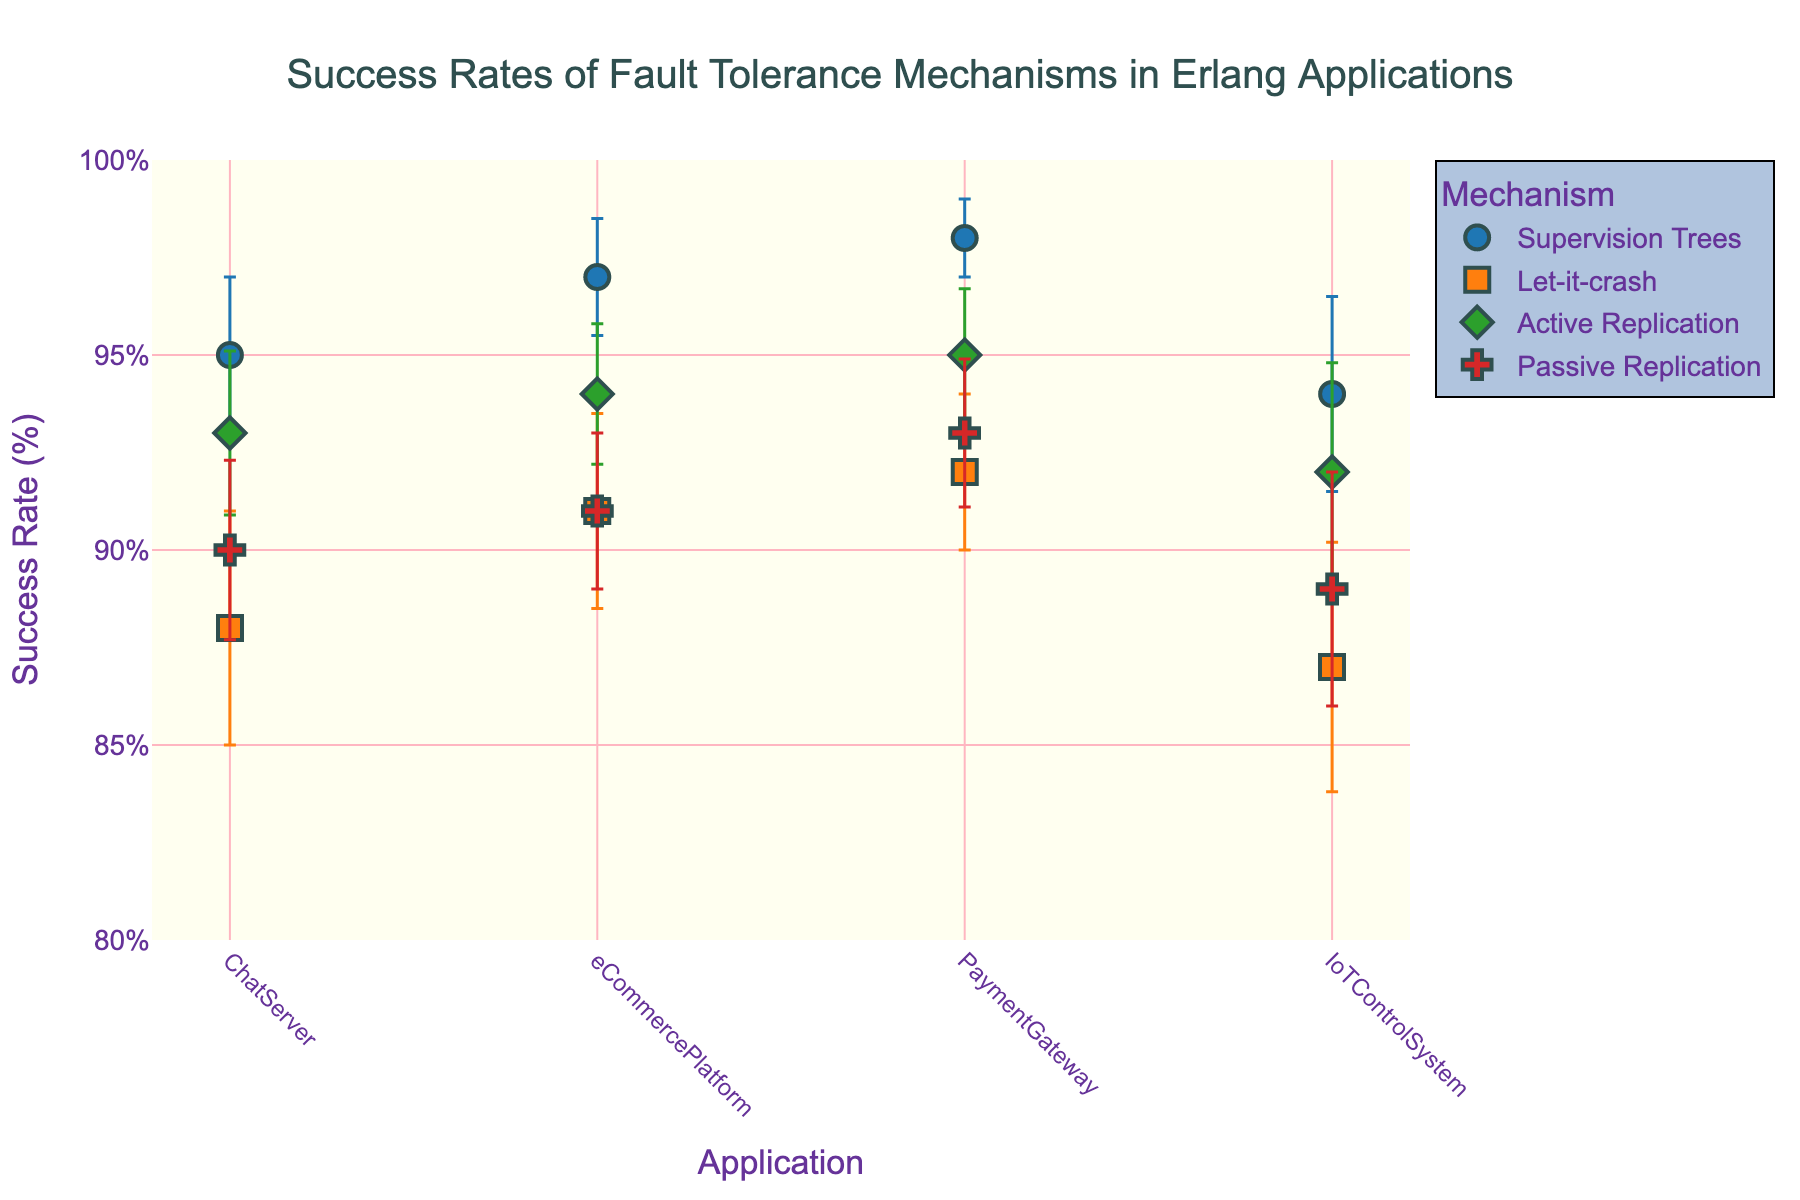What is the title of the figure? The title is displayed at the top center of the figure and reads "Success Rates of Fault Tolerance Mechanisms in Erlang Applications."
Answer: Success Rates of Fault Tolerance Mechanisms in Erlang Applications How many different applications are compared in the figure? The x-axis labels represent the different applications, and there are four distinct labels: ChatServer, eCommercePlatform, PaymentGateway, and IoTControlSystem.
Answer: 4 Which mechanism has the highest success rate for the PaymentGateway application? By observing the y-values corresponding to the "PaymentGateway" label, the highest success rate appears under "Supervision Trees" at 98%.
Answer: Supervision Trees What is the success rate for Active Replication in the ChatServer application? Locate the point corresponding to "Active Replication" for "ChatServer" on the x-axis, and check the y-axis for its success rate, which is 93%.
Answer: 93% How does the error margin of Supervision Trees for the IoTControlSystem compare to that of Let-it-crash for the same system? Observe the error bars for "Supervision Trees" and "Let-it-crash" for the "IoTControlSystem." "Supervision Trees" has an error margin of ±2.5%, while "Let-it-crash" has ±3.2%. Therefore, Let-it-crash has a higher error margin.
Answer: Let-it-crash has a higher error margin What is the combined error margin range for Passive Replication in the PaymentGateway application on the y-axis? The error margin is ±1.9%. Therefore, the success rate of 93% can range from 91.1% to 94.9%.
Answer: 91.1% to 94.9% Which mechanism shows the least average error margin across all applications? Observe the size of the error bars for each mechanism. "Supervision Trees" has the smallest error margins across all applications (1, 1.5, 2, 2.5) compared to others.
Answer: Supervision Trees How does the success rate of Let-it-crash in the eCommercePlatform compare to Supervision Trees in the same application? Compare the y-values: Let-it-crash has a success rate of 91% while Supervision Trees has 97%. Therefore, Supervision Trees has a higher success rate.
Answer: Supervision Trees is higher What is the average success rate of Supervision Trees across all applications? Calculate the average by summing the success rates of Supervision Trees (95 + 97 + 98 + 94) and then dividing by 4, which equals (384 / 4) = 96%.
Answer: 96% Which mechanism has the most consistent success rate across all applications based on the error margin? Consistency can be inferred from the smallest error margins. "Supervision Trees" shows the most consistent success rates with error margins of (2, 1.5, 1, 2.5), which are smaller compared to other mechanisms.
Answer: Supervision Trees 